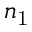Convert formula to latex. <formula><loc_0><loc_0><loc_500><loc_500>n _ { 1 }</formula> 